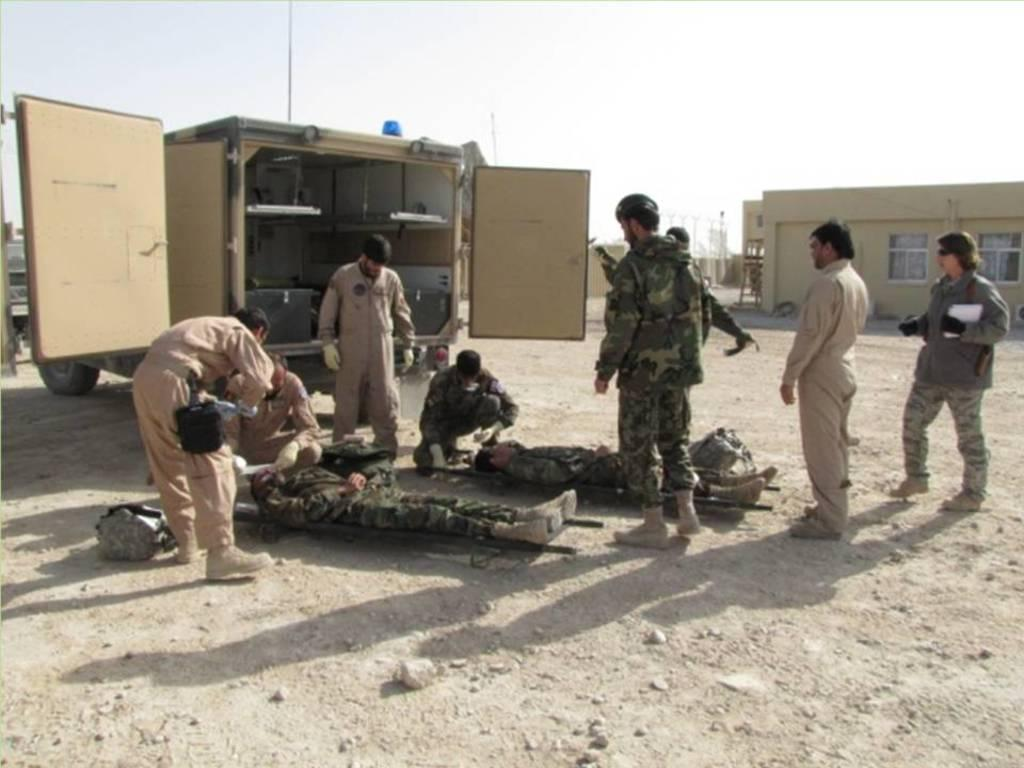Who or what can be seen in the image? There are people in the image. What objects are present that might be used for transporting injured individuals? There are stretchers in the image. What is located in the foreground of the image? There is a vehicle in the foreground. What type of structures can be seen in the background of the image? There are buildings in the background of the image. What is visible at the top of the image? There is a sky visible at the top of the image. What type of terrain is visible at the bottom of the image? There is a mud road at the bottom of the image. What type of plantation can be seen in the image? There is no plantation present in the image. How many legs does the coach have in the image? There is no coach present in the image. 